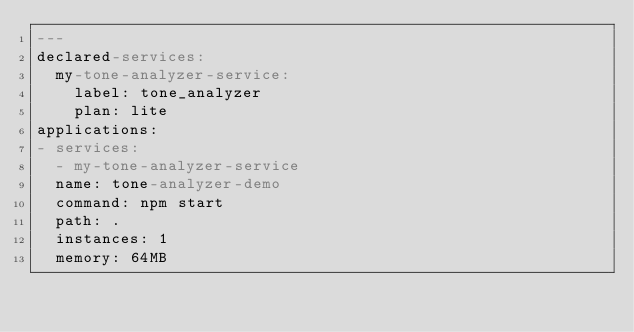Convert code to text. <code><loc_0><loc_0><loc_500><loc_500><_YAML_>---
declared-services:
  my-tone-analyzer-service:
    label: tone_analyzer
    plan: lite
applications:
- services:
  - my-tone-analyzer-service
  name: tone-analyzer-demo
  command: npm start
  path: .
  instances: 1
  memory: 64MB
</code> 